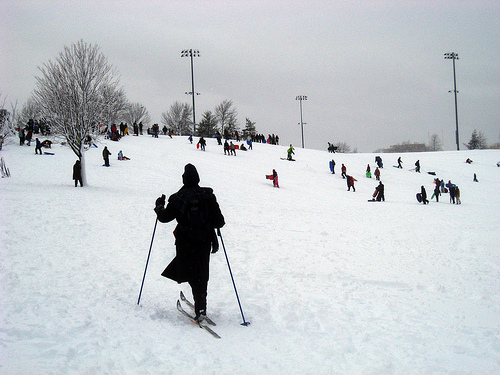Please provide a short description for this region: [0.22, 0.43, 0.52, 0.85]. A skier captured mid-action on a snowy mountain, possibly preparing for a descent. 